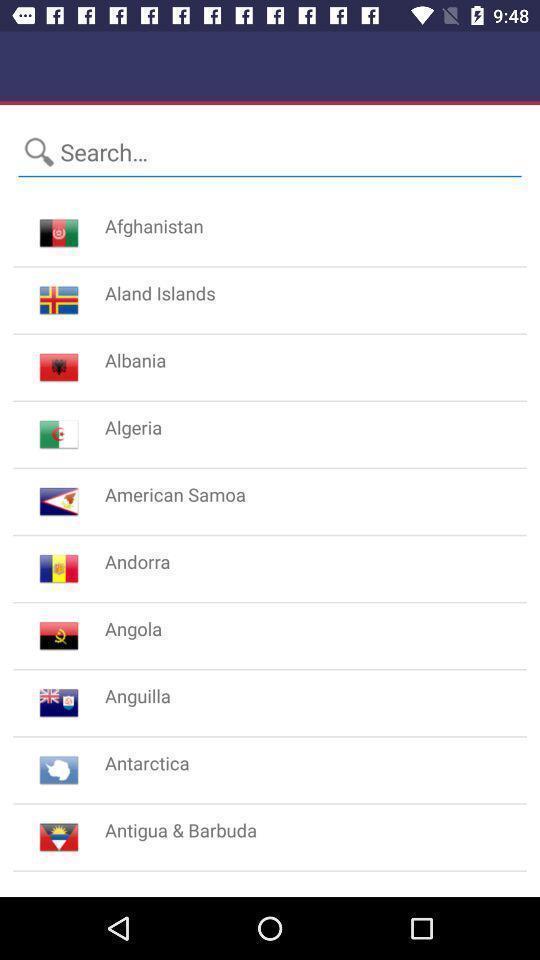Describe the visual elements of this screenshot. Search page for searching a country. 